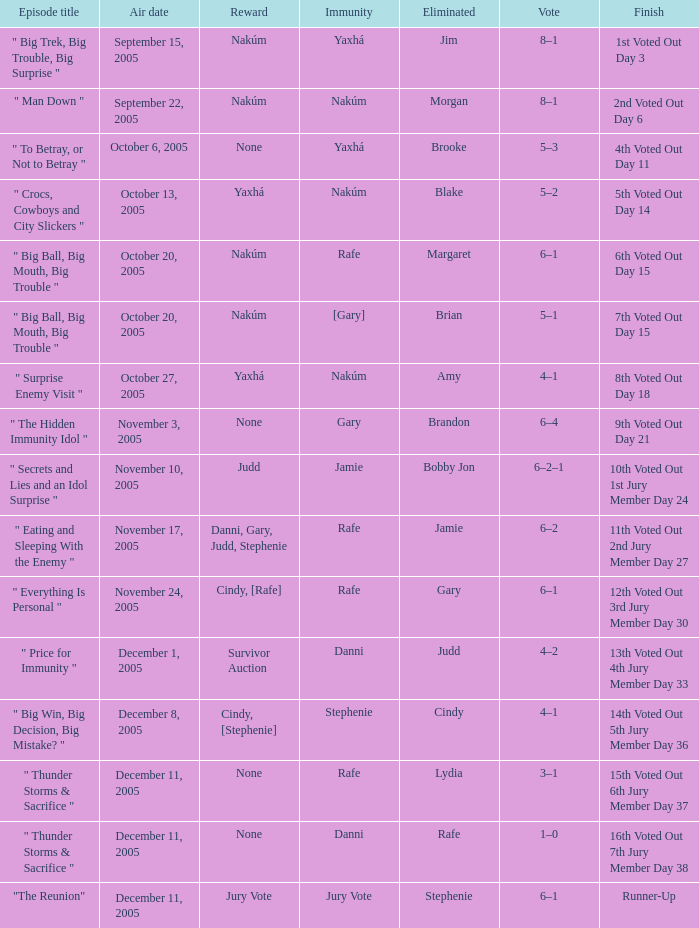When jim is eliminated what is the finish? 1st Voted Out Day 3. 